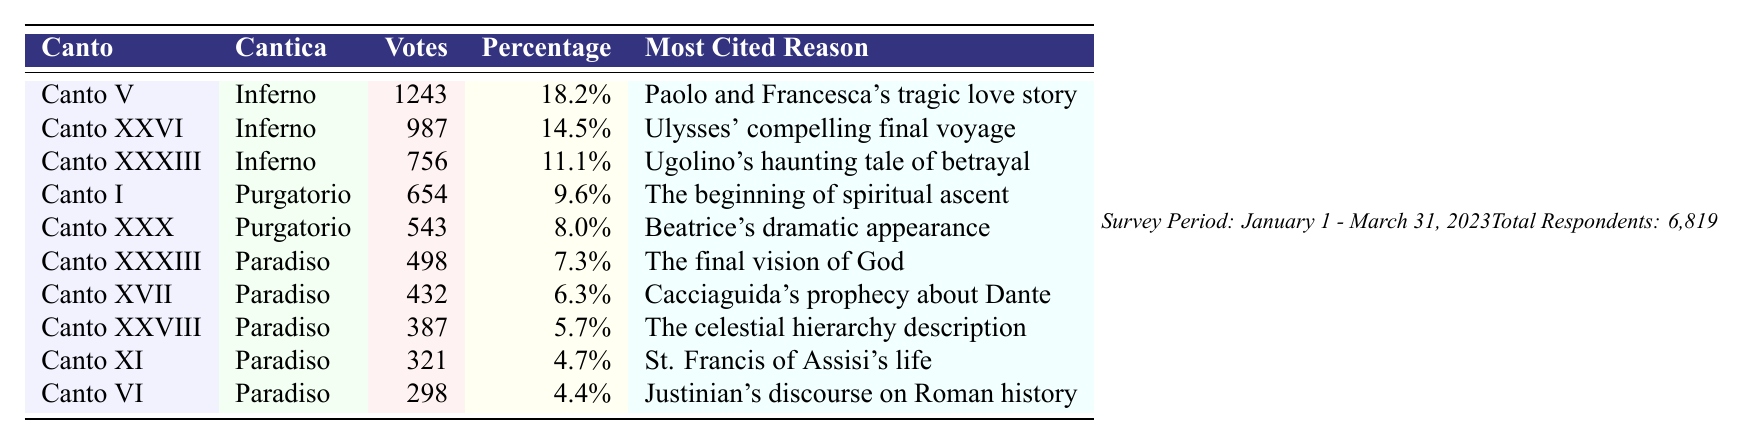What is the most voted Canto? The Canto with the highest number of votes is Canto V, which received 1243 votes.
Answer: Canto V How many votes did Canto XXXIII receive? Canto XXXIII received 498 votes, as stated in the table.
Answer: 498 What percentage of votes did Canto I receive? Canto I received 9.6% of the votes, as shown in the percentage column.
Answer: 9.6% Which Canto is associated with the theme of betrayal? Canto XXXIII is linked to betrayal due to Ugolino's haunting tale, as mentioned in the most cited reason for that Canto.
Answer: Canto XXXIII If we combine the votes for Canto V and Canto XXVI, how many total votes do they have? The total is calculated by summing their votes: 1243 (Canto V) + 987 (Canto XXVI) = 2230 votes.
Answer: 2230 What is the average percentage of votes received by all Cantos in the table? First, sum the percentages: 18.2% + 14.5% + 11.1% + 9.6% + 8.0% + 7.3% + 6.3% + 5.7% + 4.7% + 4.4% = 89.8%. Then divide by the number of Cantos: 89.8% / 10 = 8.98%.
Answer: 8.98% Did any Canto receive less than 5% of the votes? No, the lowest percentage recorded in the table is 4.4%, which is still above 5%.
Answer: No What is the total number of votes received by all Cantos listed in the table? To find the total, sum all votes: 1243 + 987 + 756 + 654 + 543 + 498 + 432 + 387 + 321 + 298 = 6819.
Answer: 6819 Which Cantos from Paradiso received more than 400 votes? Canto XXXIII (498 votes) and Canto XVII (432 votes) both exceeded 400 votes.
Answer: Canto XXXIII and Canto XVII Which Canto has a reason related to St. Francis of Assisi? Canto XI cites St. Francis of Assisi's life as the reason for its popularity.
Answer: Canto XI 